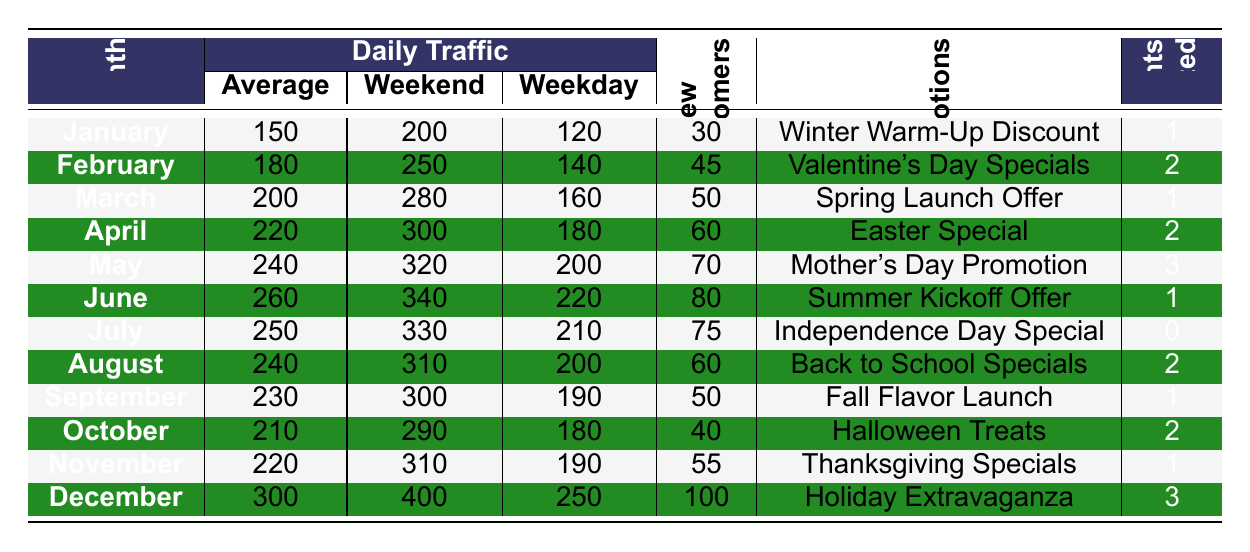What was the average daily traffic in December? The table shows that for December, the average daily traffic is specified as 300.
Answer: 300 Which month had the highest weekend traffic and what was the value? The table indicates that December experienced the highest weekend traffic at 400.
Answer: 400 How many new customers were acquired in March? According to the table, March had 50 new customers acquired as indicated in that specific row.
Answer: 50 What was the percentage increase in average daily traffic from January to February? The average daily traffic in January was 150 and in February it was 180. The increase is (180 - 150) = 30. The percentage increase is (30/150) * 100 = 20%.
Answer: 20% Which month hosted the most events and how many? The table shows that May and December hosted the most events, with 3 events each.
Answer: 3 In which month did the coffee shop chain have the least weekday traffic and what was it? The least weekday traffic is found in January with a value of 120.
Answer: 120 How many more new customers were acquired in December compared to January? In December, 100 new customers were acquired, whereas in January it was 30. The difference is (100 - 30) = 70.
Answer: 70 What was the average weekday traffic for the year? To find the average, sum all the weekday traffic values: (120 + 140 + 160 + 180 + 200 + 220 + 210 + 200 + 190 + 180 + 190 + 250) = 2,370, and divide by 12 months: 2,370 / 12 = 197.5.
Answer: 197.5 In August, did the average daily traffic exceed the average daily traffic in June? August had an average daily traffic of 240, while June had 260, so August did not exceed June's average.
Answer: No How many total new customers were acquired from March to June? Adding the new customers from March to June: 50 (March) + 60 (April) + 70 (May) + 80 (June) = 260.
Answer: 260 Which month had the highest traffic increase between the weekdays and weekends, and what was that increase? February has the highest increase, with weekend traffic of 250 and weekday traffic of 140, resulting in an increase of (250 - 140) = 110.
Answer: February, 110 